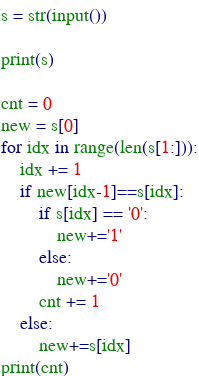Convert code to text. <code><loc_0><loc_0><loc_500><loc_500><_Python_>s = str(input())

print(s)

cnt = 0
new = s[0]
for idx in range(len(s[1:])):
    idx += 1
    if new[idx-1]==s[idx]:
        if s[idx] == '0':
            new+='1'
        else:
            new+='0'
        cnt += 1
    else:
        new+=s[idx]
print(cnt)</code> 